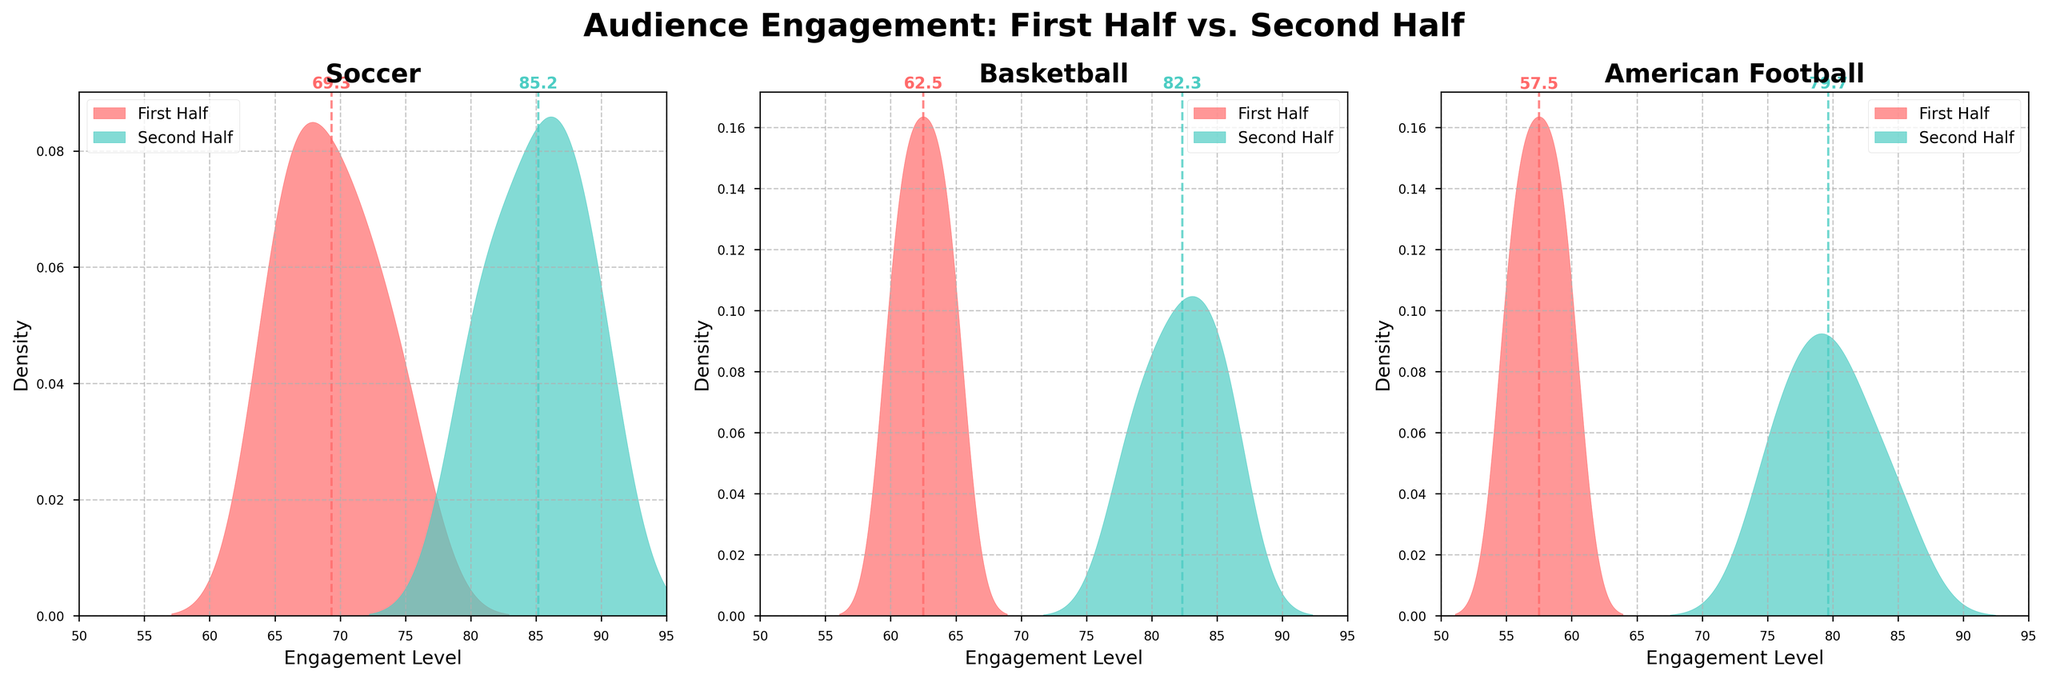What's the title of the plot? The title of the plot is displayed at the top center of the figure.
Answer: Audience Engagement: First Half vs. Second Half What sports are represented in the plots? The titles of the subplots indicate the sports displayed, which are listed at the top of each subplot.
Answer: Soccer, Basketball, American Football Which phase has the highest mean audience engagement in American Football? The subplot for American Football shows a dashed vertical line representing the mean engagement for each phase. The line for the Second Half is further right, indicating a higher mean.
Answer: Second Half What is the mean engagement level in the first half of the Soccer game? Look at the dashed vertical line in the Soccer subplot representing the First Half (colored in the corresponding color) and read the value labeled next to it.
Answer: Approximately 69.4 Which sport shows the most considerable increase in audience engagement from the first half to the second half? Compare the difference in the positions of the vertical lines representing the means for each phase in the three subplots.
Answer: American Football Is the engagement level generally higher in the second half across all sports? Assess the positions of the density curves and the vertical lines indicating mean engagement levels for the First Half and Second Half in each subplot.
Answer: Yes What is the approximate mean engagement level in the second half for Basketball? Look for the labeled point where the dashed vertical line intersects the density curve for the second half in the Basketball subplot.
Answer: Approximately 82.3 Which sport has the smallest engagement level in the first half? Compare the positions of the density peaks (highest points) in the First Half across all three sports subplots.
Answer: American Football How does the spread (variability) of engagement compare between the first half and the second half in Soccer? Evaluate the width and shape of the density curves for Soccer in both phases. The curve with a broader base indicates higher variability.
Answer: The first half shows less spread; the second half has more spread Are the distributions for both phases in Basketball mostly overlapping or separated? Examine the density curves in the Basketball subplot. If they have significant overlap, they are close; if they are apart, they are separated.
Answer: Mostly separated 